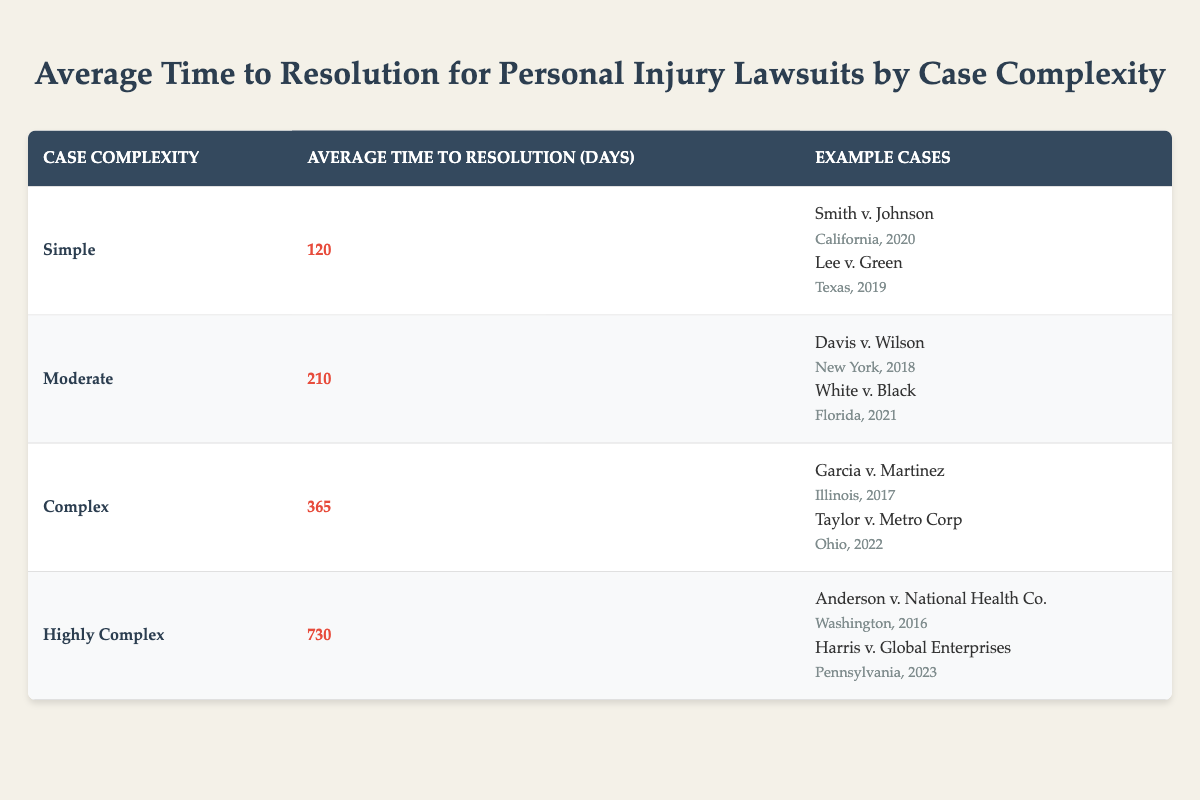What is the average time to resolution for simple personal injury lawsuits? The table shows that the average time to resolution for simple personal injury lawsuits is listed directly under the "Average Time to Resolution (Days)" column for the "Simple" case complexity. This value is 120 days.
Answer: 120 days How long does it take, on average, to resolve highly complex personal injury lawsuits? Referring to the table, the average time to resolution for highly complex personal injury lawsuits can be found in the "Average Time to Resolution (Days)" column corresponding to the "Highly Complex" case complexity, which is 730 days.
Answer: 730 days What are the example cases for moderate complexity lawsuits? In the table, the "Example Cases" section for moderate complexity lists two cases: "Davis v. Wilson" from New York in 2018 and "White v. Black" from Florida in 2021.
Answer: Davis v. Wilson, White v. Black Which case complexity takes the least time to resolve? The table clearly states the average times for each complexity level. The "Simple" cases have the shortest average time of 120 days, making it the least time-consuming complexity.
Answer: Simple What is the difference in average resolution time between complex and highly complex lawsuits? For complex lawsuits, the average time is 365 days, and for highly complex lawsuits, it is 730 days. The difference can be calculated as 730 - 365 = 365 days.
Answer: 365 days Are there any example cases listed for complex lawsuits that are from Illinois? Yes, the table lists "Garcia v. Martinez" as an example case for complex lawsuits, which is from Illinois.
Answer: Yes If you were to average the resolution times for all the complexities, what would it be? To find the average, sum the average resolution times: 120 + 210 + 365 + 730 = 1425 days. Then divide by the number of complexities (4): 1425/4 = 356.25 days.
Answer: 356.25 days Is the time to resolution longer for moderate cases than for simple cases? The average time for moderate cases is 210 days, while for simple cases it is 120 days. Since 210 is greater than 120, the answer is yes.
Answer: Yes What is the highest average time to resolution in the table? By examining the values in the "Average Time to Resolution (Days)" column, the highest average time is found under the "Highly Complex" category at 730 days.
Answer: 730 days How many days does it take, on average, to resolve moderate personal injury lawsuits? By checking the table for the "Moderate" case complexity, the average resolution time is directly stated as 210 days.
Answer: 210 days 